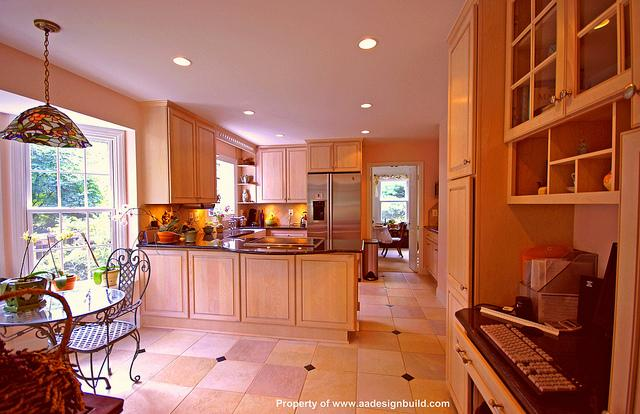What shape is the black tiles on the floor?

Choices:
A) triangle
B) oval
C) square
D) diamond diamond 